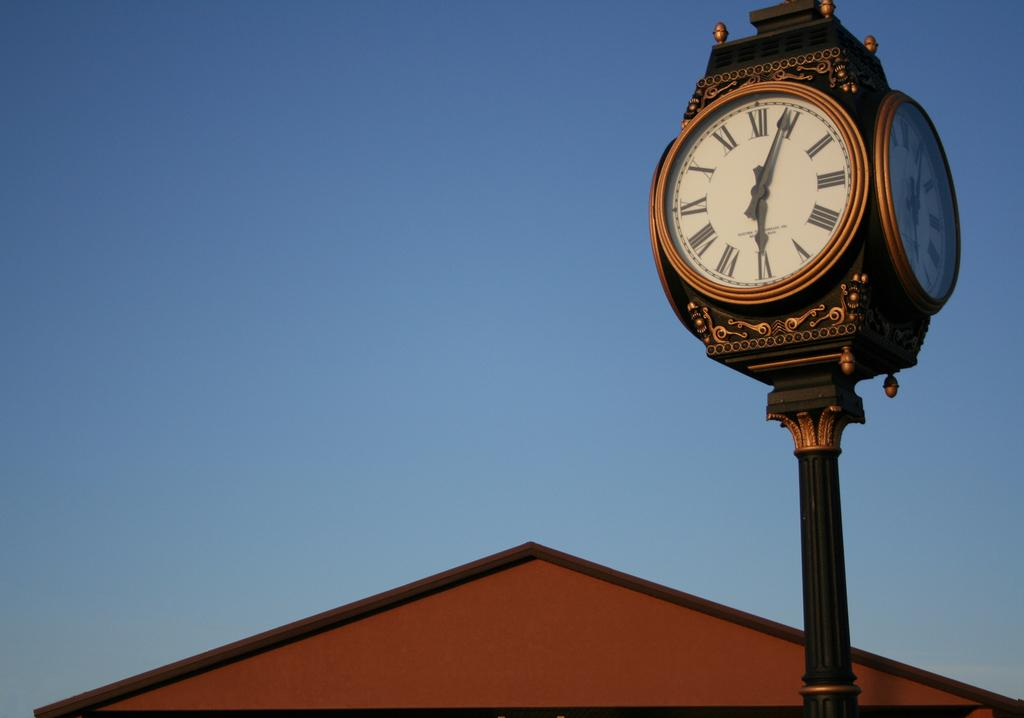<image>
Present a compact description of the photo's key features. a clock tower with one of the dials pointing at 1 